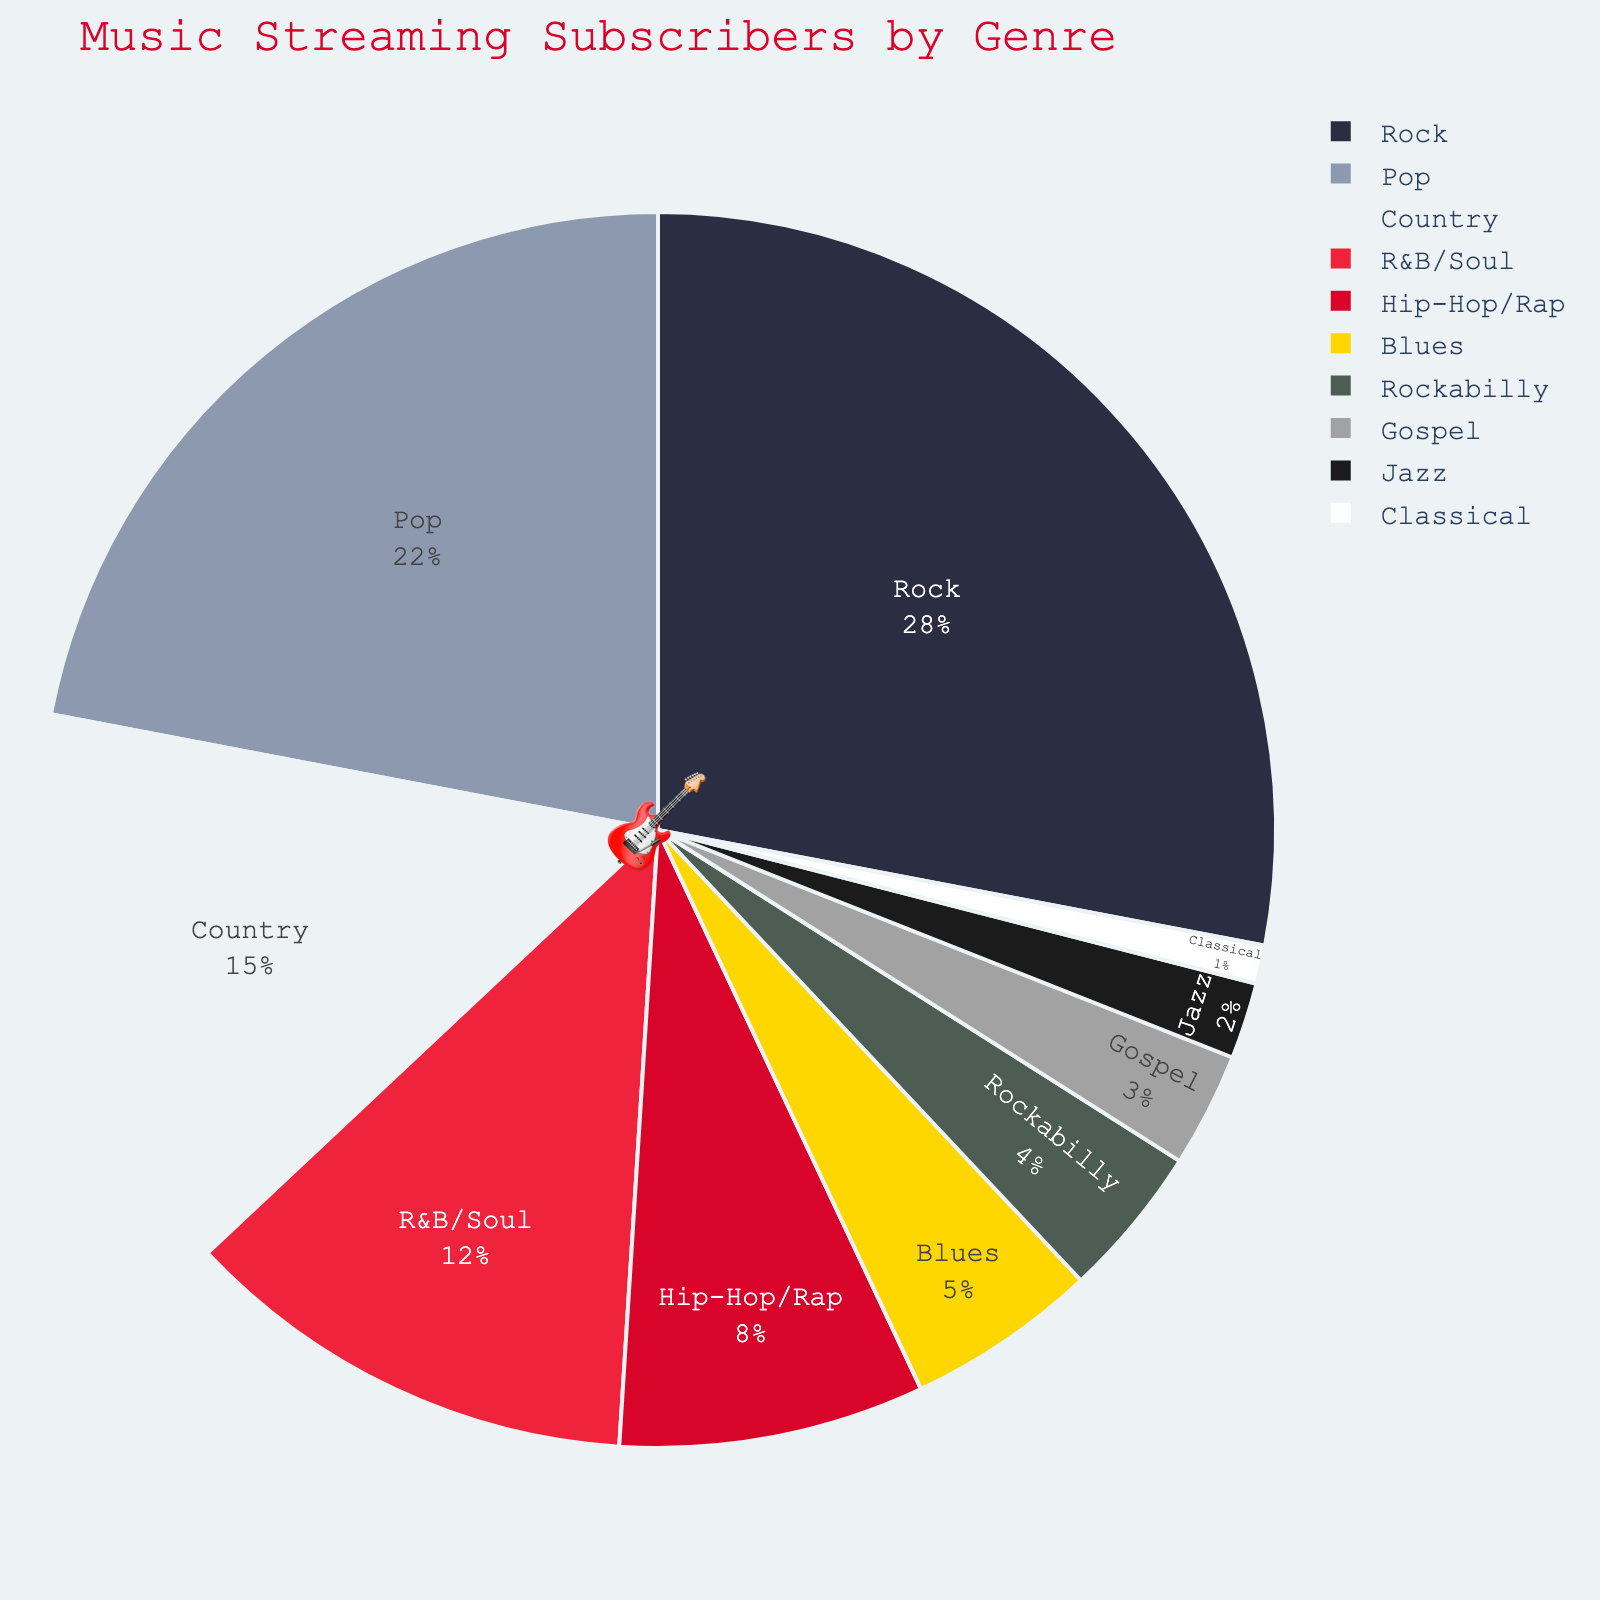What's the most popular music genre among subscribers? The pie chart shows that Rock has the largest section, indicating it's the most popular genre among the subscribers.
Answer: Rock What percentage of subscribers prefer Rockabilly? By looking at the pie chart, the Rockabilly section makes up 4% of the total.
Answer: 4% Which genre has a higher percentage of subscribers, Country or R&B/Soul? The pie chart indicates that Country has 15% while R&B/Soul has 12%, so Country has a higher percentage.
Answer: Country What's the combined percentage of Jazz and Classical music subscribers? Jazz has 2% and Classical has 1%, so the combined percentage is 2% + 1% = 3%.
Answer: 3% How does the percentage of Blues subscribers compare to that of Hip-Hop/Rap subscribers? Blues has 5% while Hip-Hop/Rap has 8%, so Blues has a lower percentage than Hip-Hop/Rap.
Answer: Hip-Hop/Rap has a higher percentage Do Gospel and Rockabilly make up more than 5% of the total subscribers combined? Gospel has 3% and Rockabilly has 4%, so combined they make up 3% + 4% = 7%, which is more than 5%.
Answer: Yes What's the difference in percentage between the most popular and the least popular genres? Rock is the most popular with 28%, and Classical is the least popular with 1%. The difference is 28% - 1% = 27%.
Answer: 27% What's the percentage of subscribers preferring genres other than Pop and Rock? Pop has 22% and Rock has 28%, so combined they are 50%. Subtracting this from 100% gives us 100% - 50% = 50%.
Answer: 50% Which genres have less than 5% of subscribers each? The pie chart shows that Blues (5%), Rockabilly (4%), Gospel (3%), Jazz (2%), and Classical (1%) each have less than 5%.
Answer: Blues, Rockabilly, Gospel, Jazz, and Classical What is the average percentage of subscribers for Pop, Country, and R&B/Soul? Pop has 22%, Country has 15%, and R&B/Soul has 12%. Their average percentage is (22% + 15% + 12%) / 3 = 16.33%.
Answer: 16.33% 